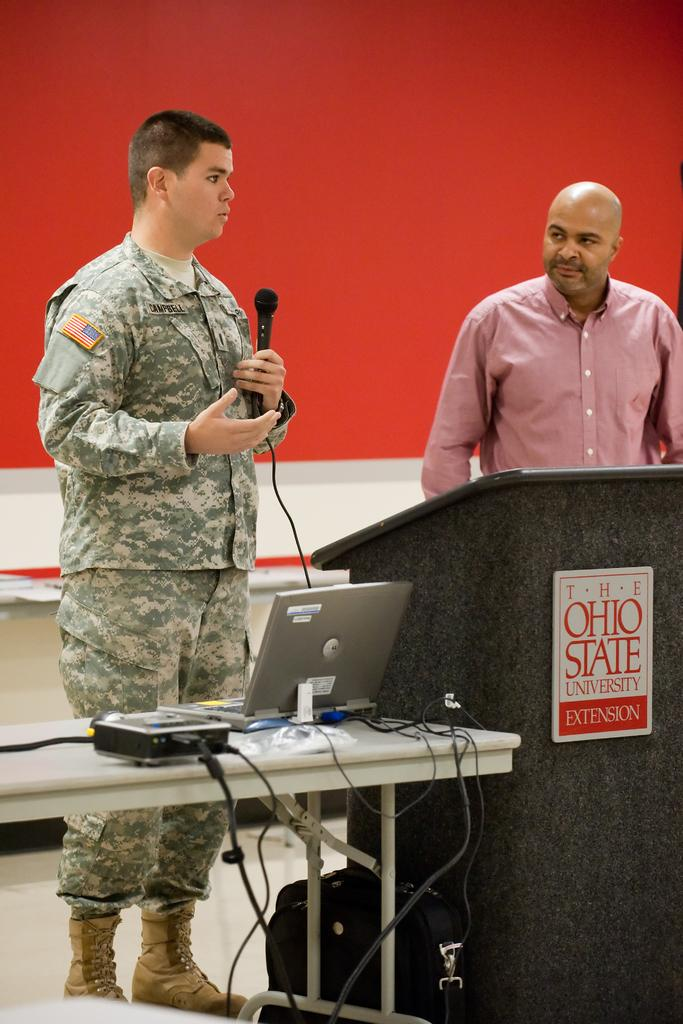What can be seen in the background of the image? There is a wall in the image. How many people are present in the image? There are two people in the image. What are the people doing in the image? The people are standing. What is on the table in the image? There is a projector and a laptop on the table. What type of glue is being used to measure the distance between the two people in the image? There is no glue or measuring activity present in the image. How many matches are visible on the table in the image? There are no matches present in the image; only a projector and a laptop are visible on the table. 